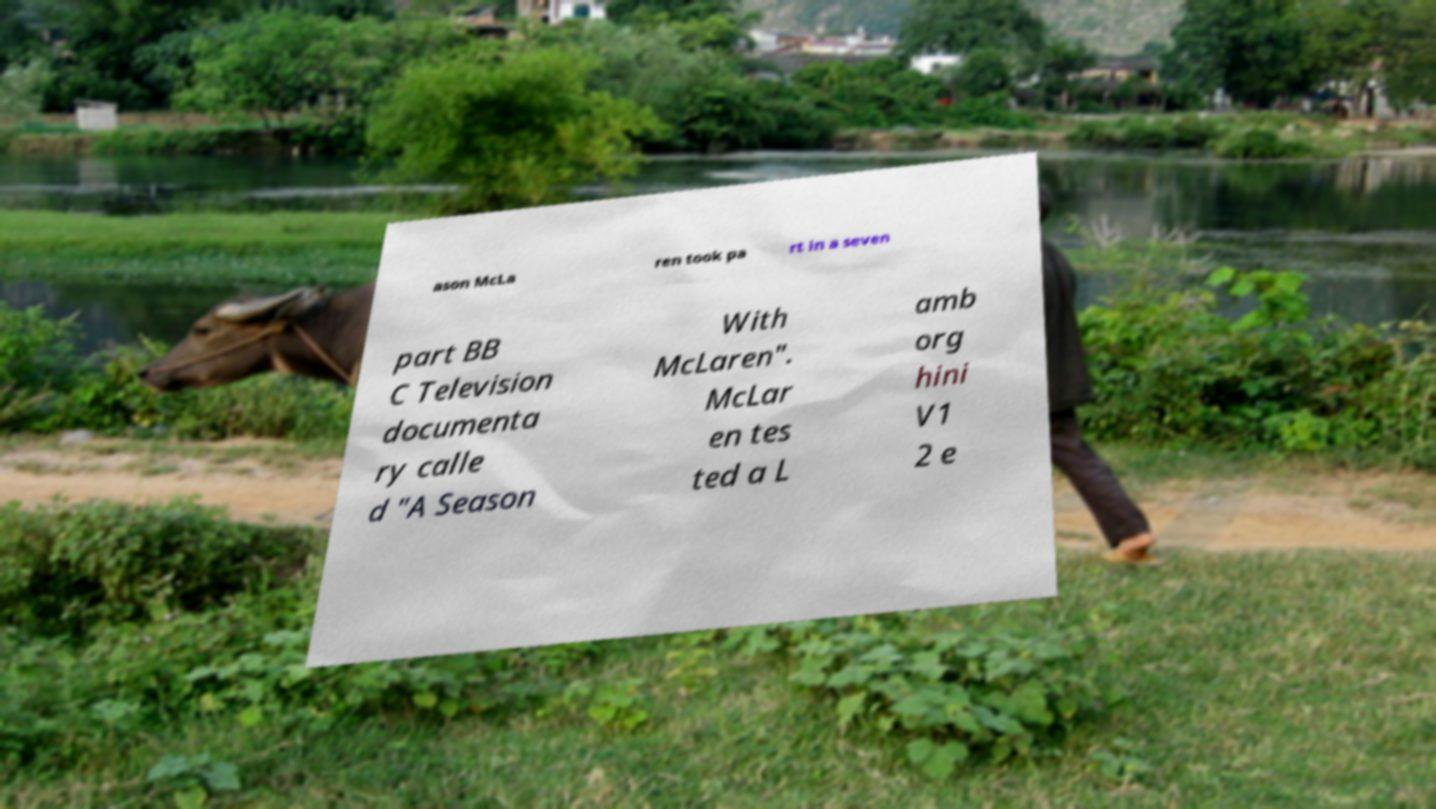Please identify and transcribe the text found in this image. ason McLa ren took pa rt in a seven part BB C Television documenta ry calle d "A Season With McLaren". McLar en tes ted a L amb org hini V1 2 e 